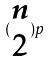Convert formula to latex. <formula><loc_0><loc_0><loc_500><loc_500>( \begin{matrix} n \\ 2 \end{matrix} ) p</formula> 